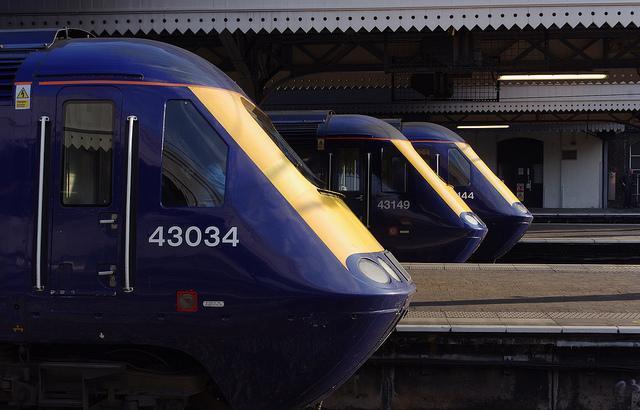What surface allows the trains to be mobile?
Answer the question by selecting the correct answer among the 4 following choices.
Options: Rails, cement, asphalt, pavement. Rails. 